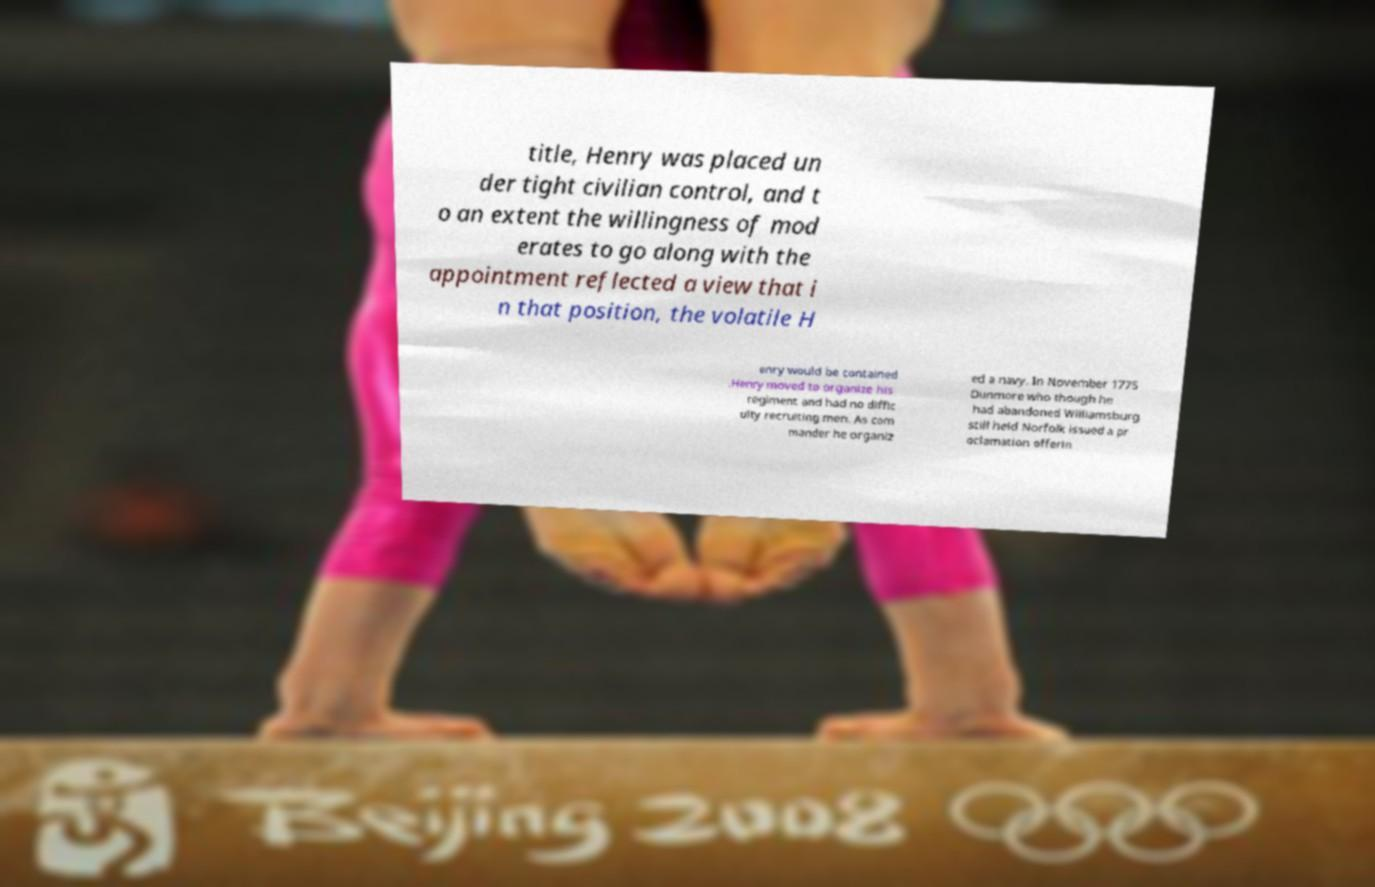There's text embedded in this image that I need extracted. Can you transcribe it verbatim? title, Henry was placed un der tight civilian control, and t o an extent the willingness of mod erates to go along with the appointment reflected a view that i n that position, the volatile H enry would be contained .Henry moved to organize his regiment and had no diffic ulty recruiting men. As com mander he organiz ed a navy. In November 1775 Dunmore who though he had abandoned Williamsburg still held Norfolk issued a pr oclamation offerin 